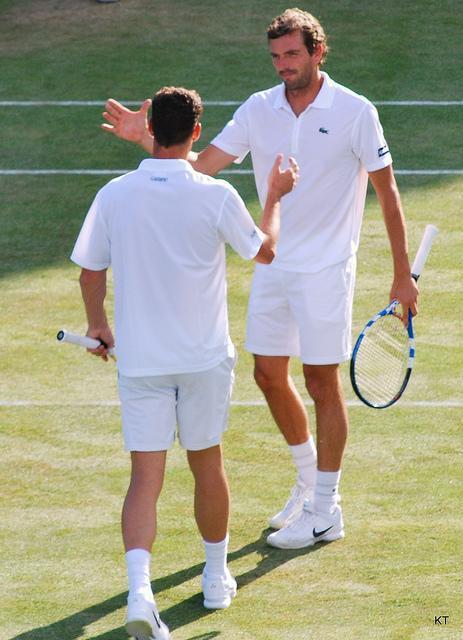How many people are there?
Give a very brief answer. 2. 